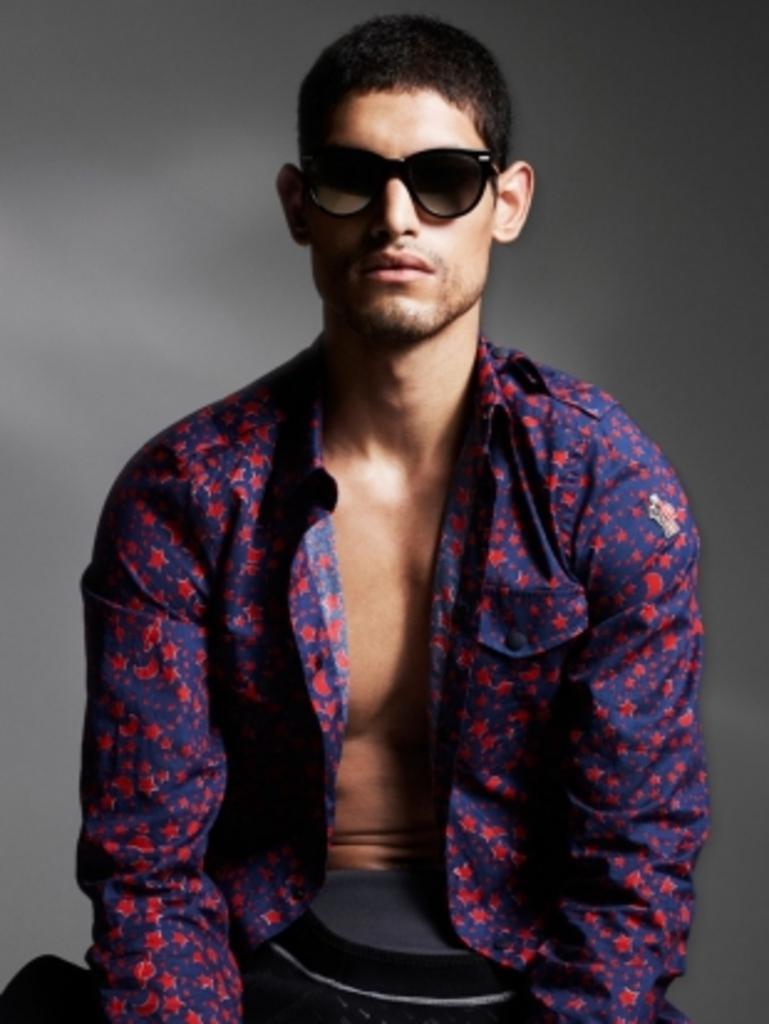How would you summarize this image in a sentence or two? In this picture I can observe a man wearing purple color shirt and black color spectacles. The background is in grey color. 